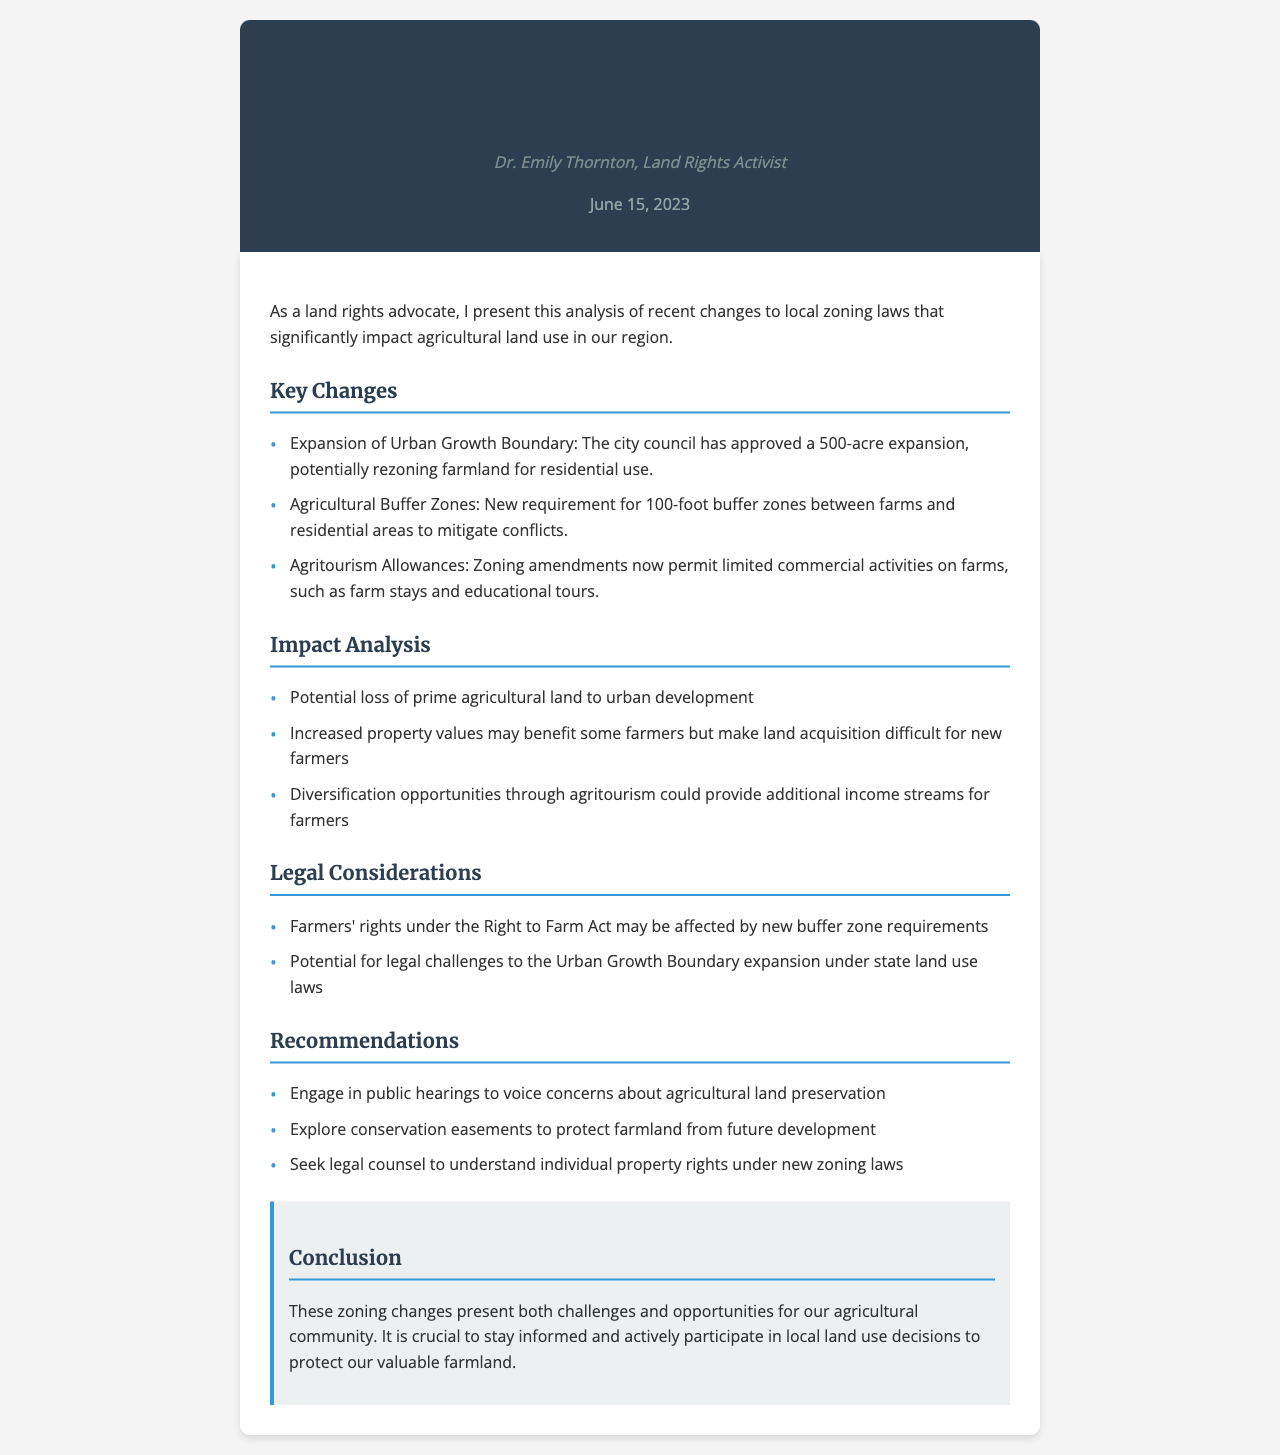What is the title of the document? The title is prominently displayed in the header of the fax.
Answer: Recent Changes to Local Zoning Laws Affecting Agricultural Land Use Who authored the document? The author's name is mentioned in the fax header.
Answer: Dr. Emily Thornton When was the document dated? The date is specified right under the author's name in the fax header.
Answer: June 15, 2023 What is the area of the Urban Growth Boundary expansion? The document provides a specific area regarding this expansion.
Answer: 500 acres What is the required buffer zone distance? The document states the new requirement for buffer zones in a specific unit of measurement.
Answer: 100-foot What potential benefit is mentioned for farmers from the zoning changes? This benefit is found in the impact analysis section of the document.
Answer: Additional income streams What legal act may be affected by the new buffer zone requirements? The document notes a specific act related to farmers' rights.
Answer: Right to Farm Act What does the document recommend regarding land preservation? Recommendations are listed for actions farmers should consider.
Answer: Engage in public hearings What type of activities are now permitted on farms according to the zoning amendments? The document outlines specific commercial activities allowed under new zoning laws.
Answer: Agritourism 